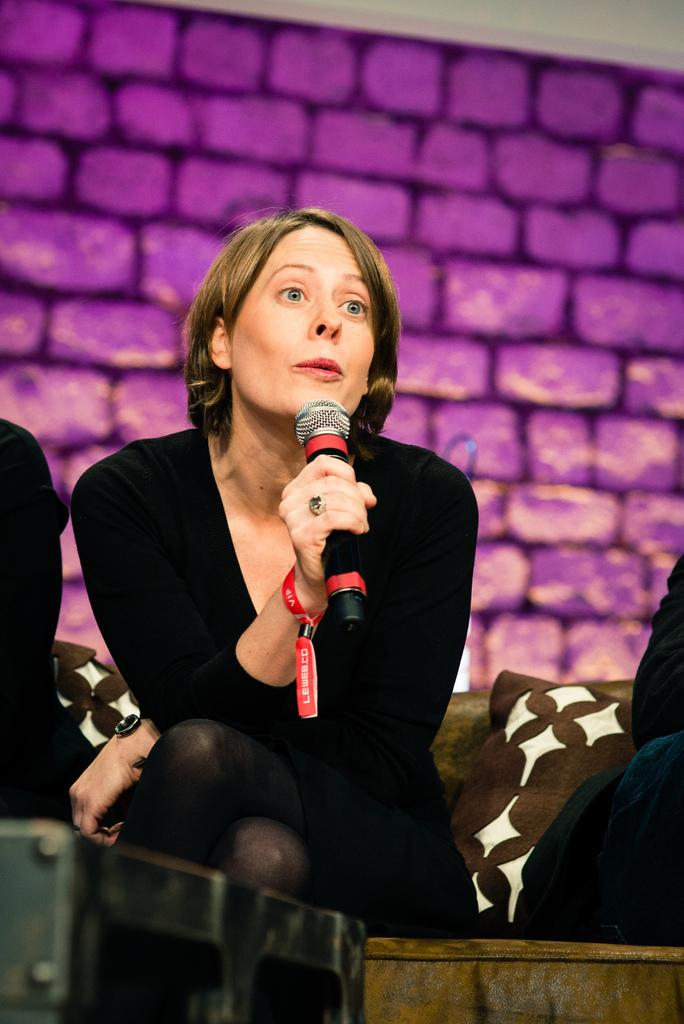How many people are in total can be seen in the image? There are people in the image, but the exact number is not specified. What is the woman in the middle of the image doing? The woman in the middle of the image is talking with the help of a microphone. What can be seen behind the people in the image? There is a wall in the background of the image. What type of snakes can be seen slithering on the wall in the image? There are no snakes present in the image; the wall in the background is clear of any snakes. 